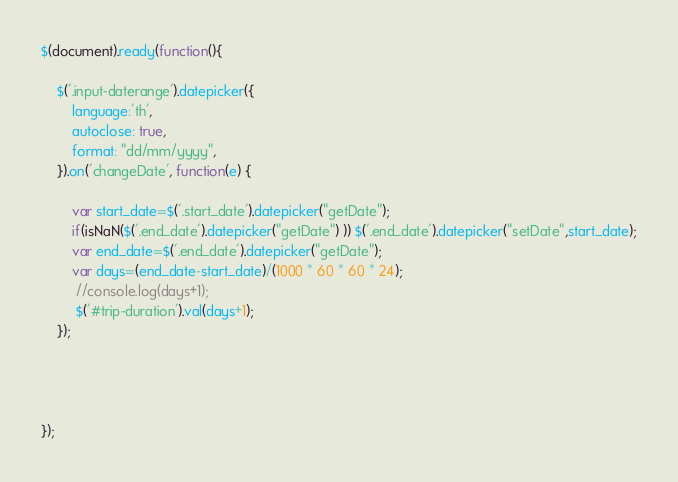<code> <loc_0><loc_0><loc_500><loc_500><_JavaScript_>$(document).ready(function(){

    $('.input-daterange').datepicker({
        language:'th',
        autoclose: true,
        format: "dd/mm/yyyy",
    }).on('changeDate', function(e) {
        
        var start_date=$('.start_date').datepicker("getDate");
        if(isNaN($('.end_date').datepicker("getDate") )) $('.end_date').datepicker("setDate",start_date);
        var end_date=$('.end_date').datepicker("getDate");
        var days=(end_date-start_date)/(1000 * 60 * 60 * 24);
         //console.log(days+1);
         $('#trip-duration').val(days+1);
    });

    


});</code> 